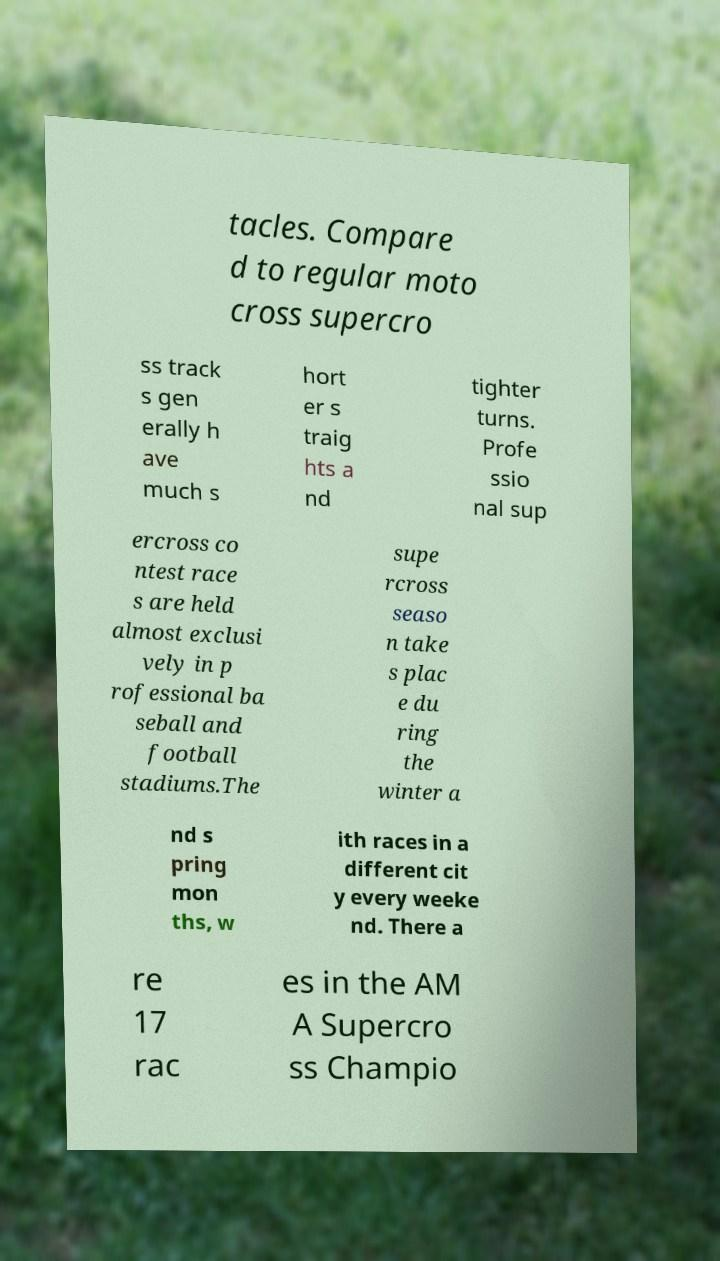Can you accurately transcribe the text from the provided image for me? tacles. Compare d to regular moto cross supercro ss track s gen erally h ave much s hort er s traig hts a nd tighter turns. Profe ssio nal sup ercross co ntest race s are held almost exclusi vely in p rofessional ba seball and football stadiums.The supe rcross seaso n take s plac e du ring the winter a nd s pring mon ths, w ith races in a different cit y every weeke nd. There a re 17 rac es in the AM A Supercro ss Champio 